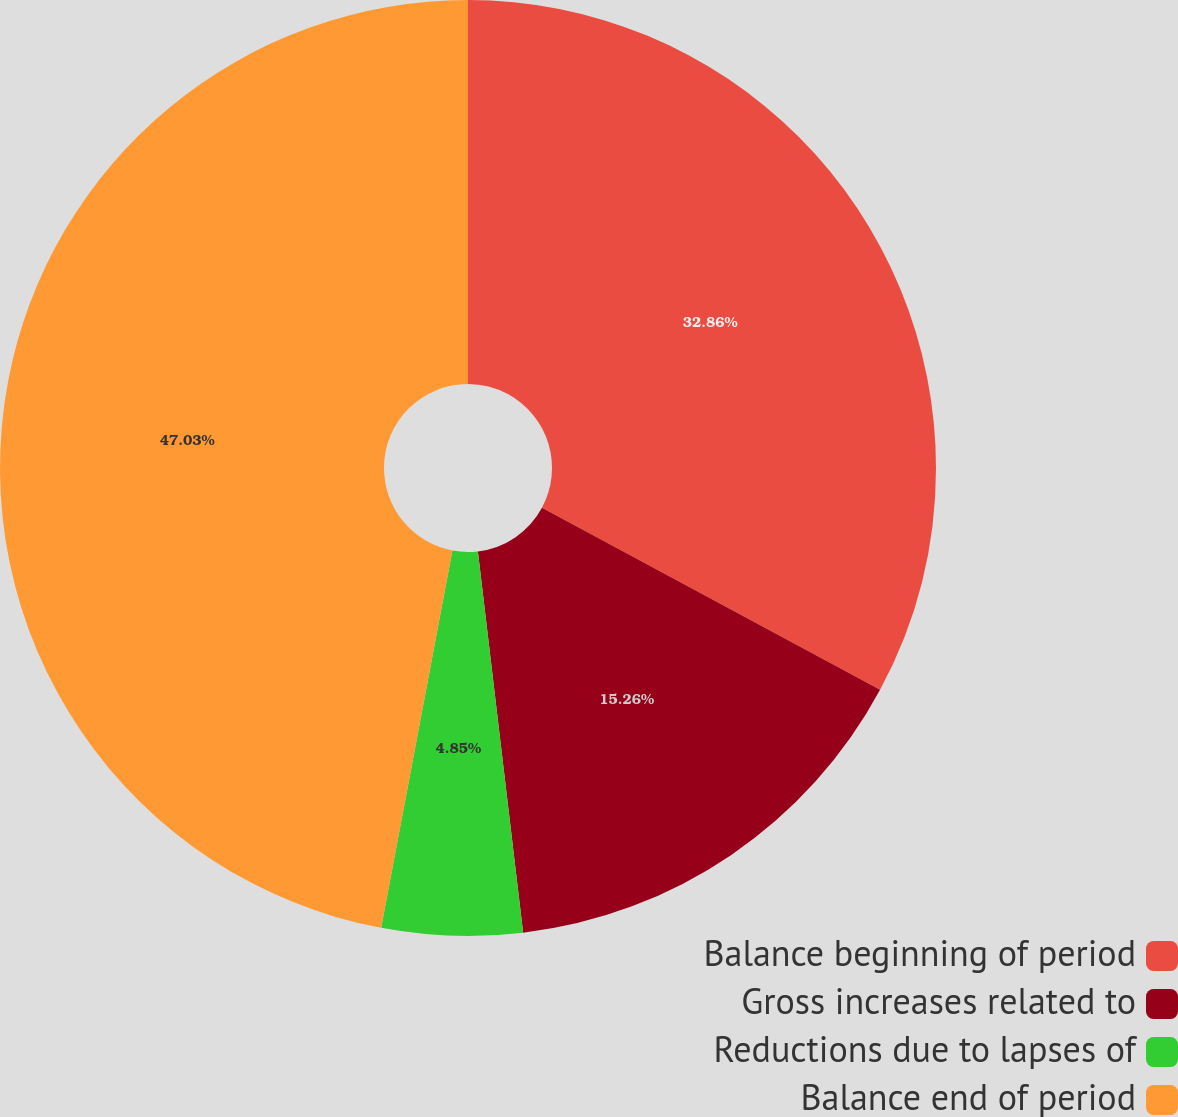Convert chart. <chart><loc_0><loc_0><loc_500><loc_500><pie_chart><fcel>Balance beginning of period<fcel>Gross increases related to<fcel>Reductions due to lapses of<fcel>Balance end of period<nl><fcel>32.86%<fcel>15.26%<fcel>4.85%<fcel>47.03%<nl></chart> 